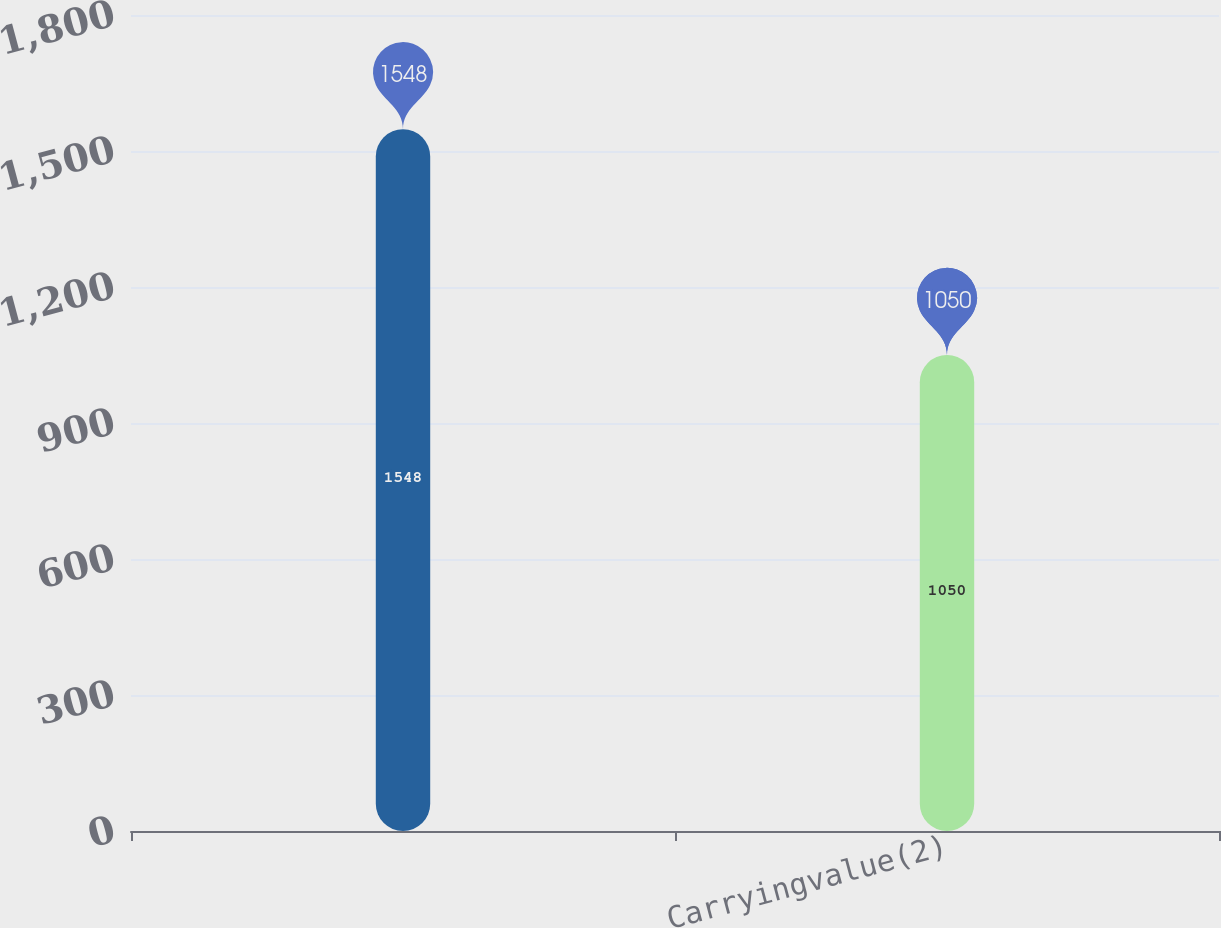<chart> <loc_0><loc_0><loc_500><loc_500><bar_chart><ecel><fcel>Carryingvalue(2)<nl><fcel>1548<fcel>1050<nl></chart> 